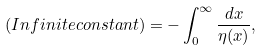<formula> <loc_0><loc_0><loc_500><loc_500>( I n f i n i t e c o n s t a n t ) = - \int _ { 0 } ^ { \infty } \frac { d x } { \eta ( x ) } ,</formula> 